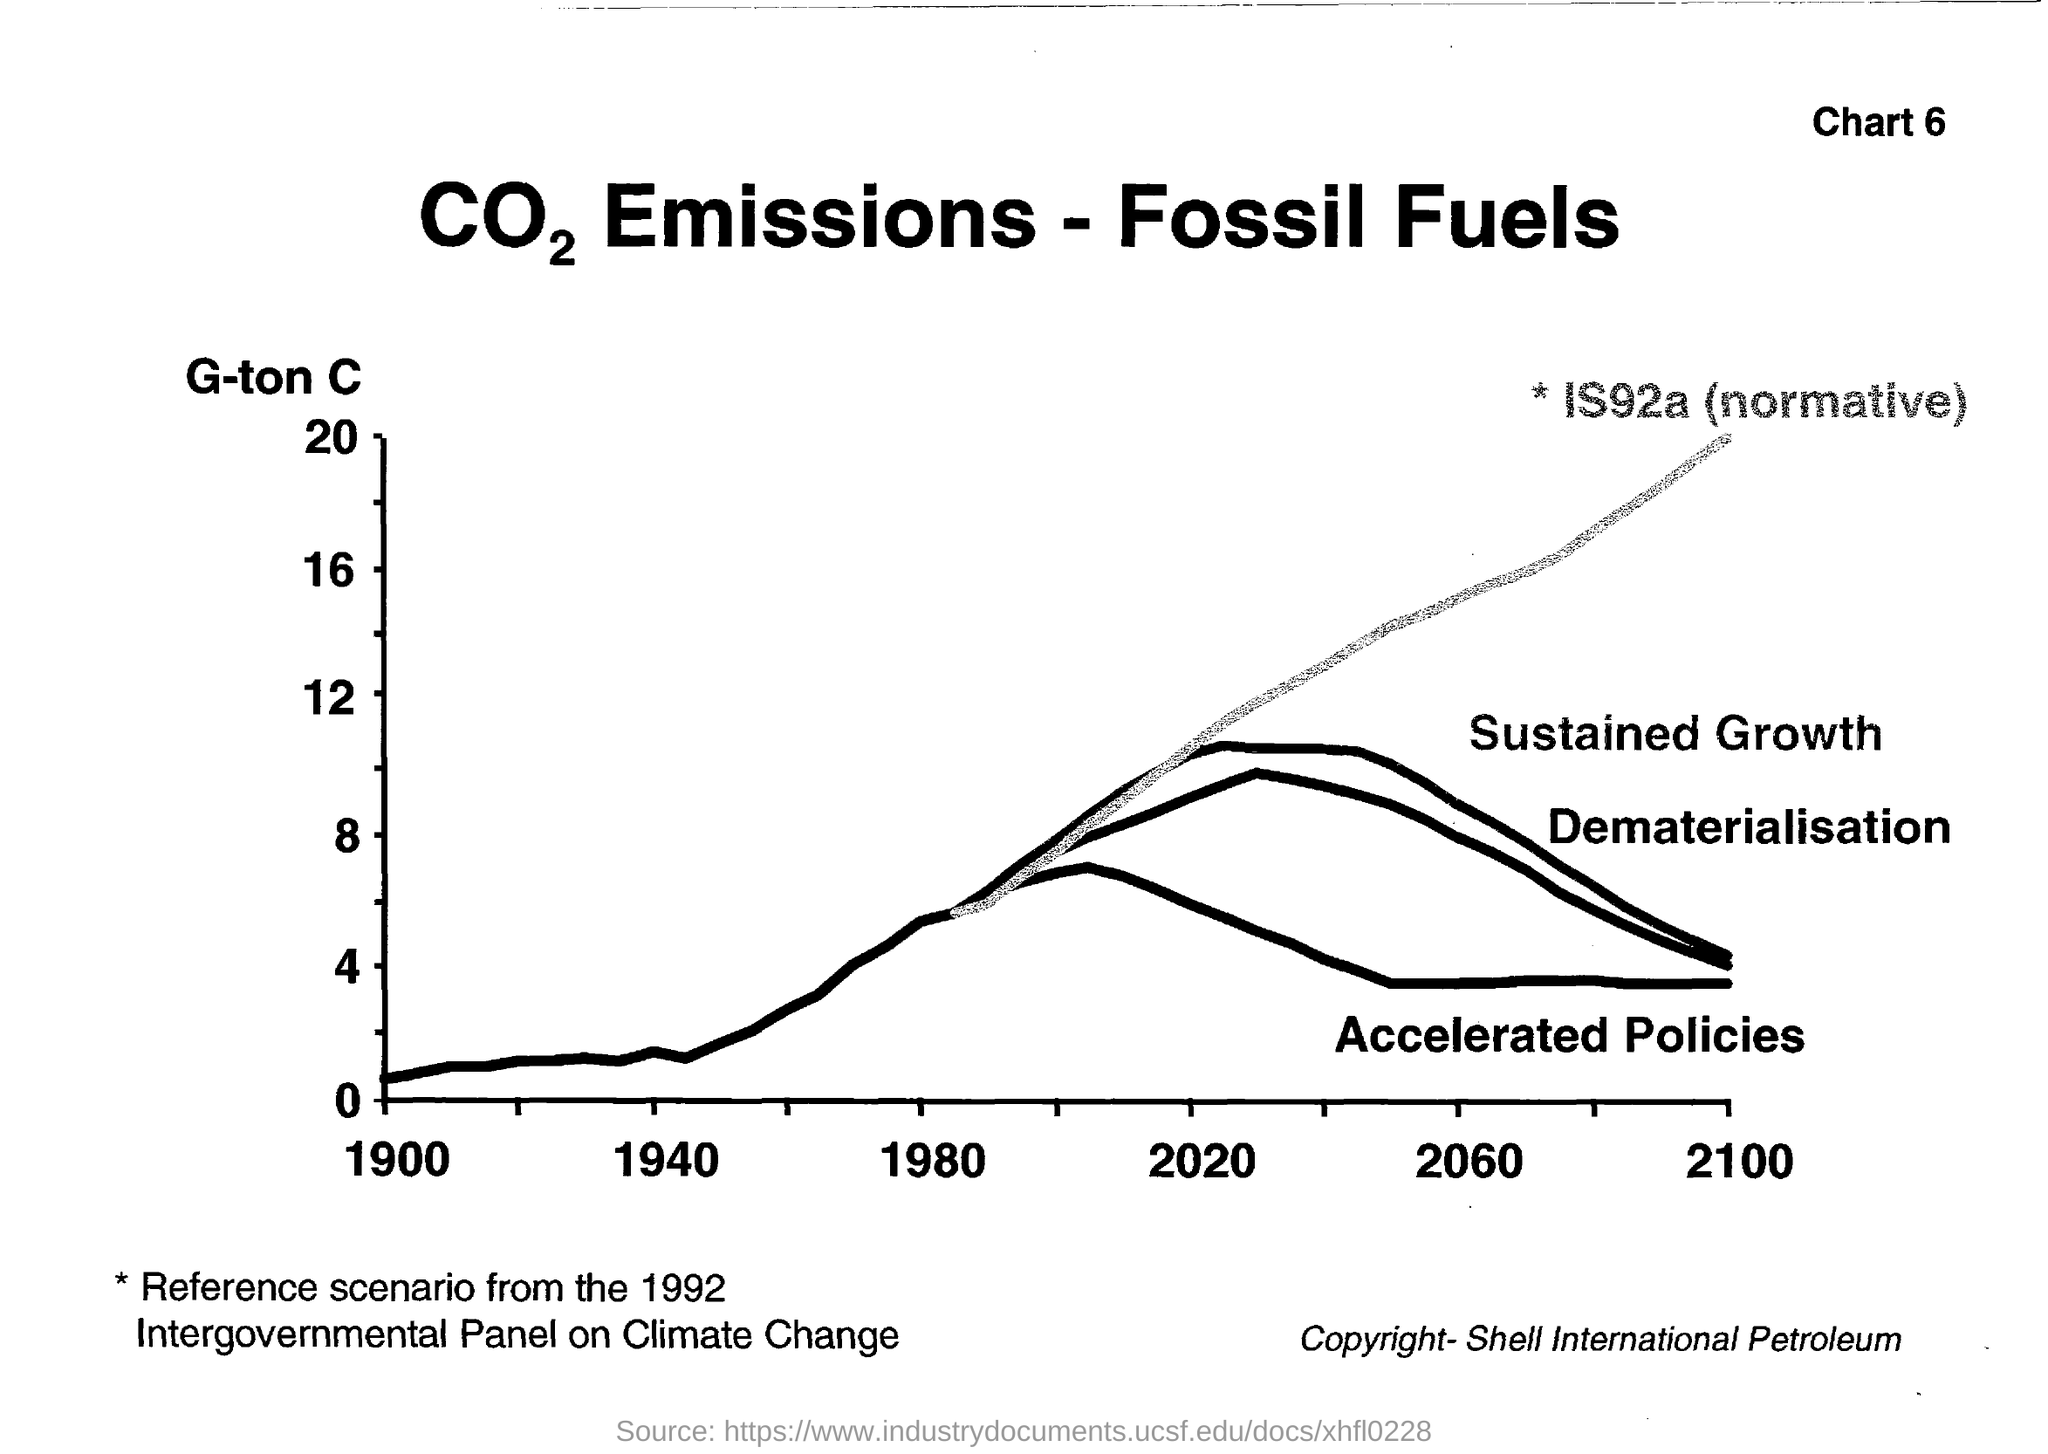What is the chart number specified in the header?
Ensure brevity in your answer.  6. What is the highest value in Y-axis?
Your response must be concise. 20. In which year the 'Sustained Growth' and 'Dematerialisation' become same after 2020?
Ensure brevity in your answer.  2100. Who has copyright on this document?
Give a very brief answer. Shell International Petroleum. From where is the Reference scenario chosen?
Provide a succinct answer. From the 1992 intergovernmental panel on climate change. 